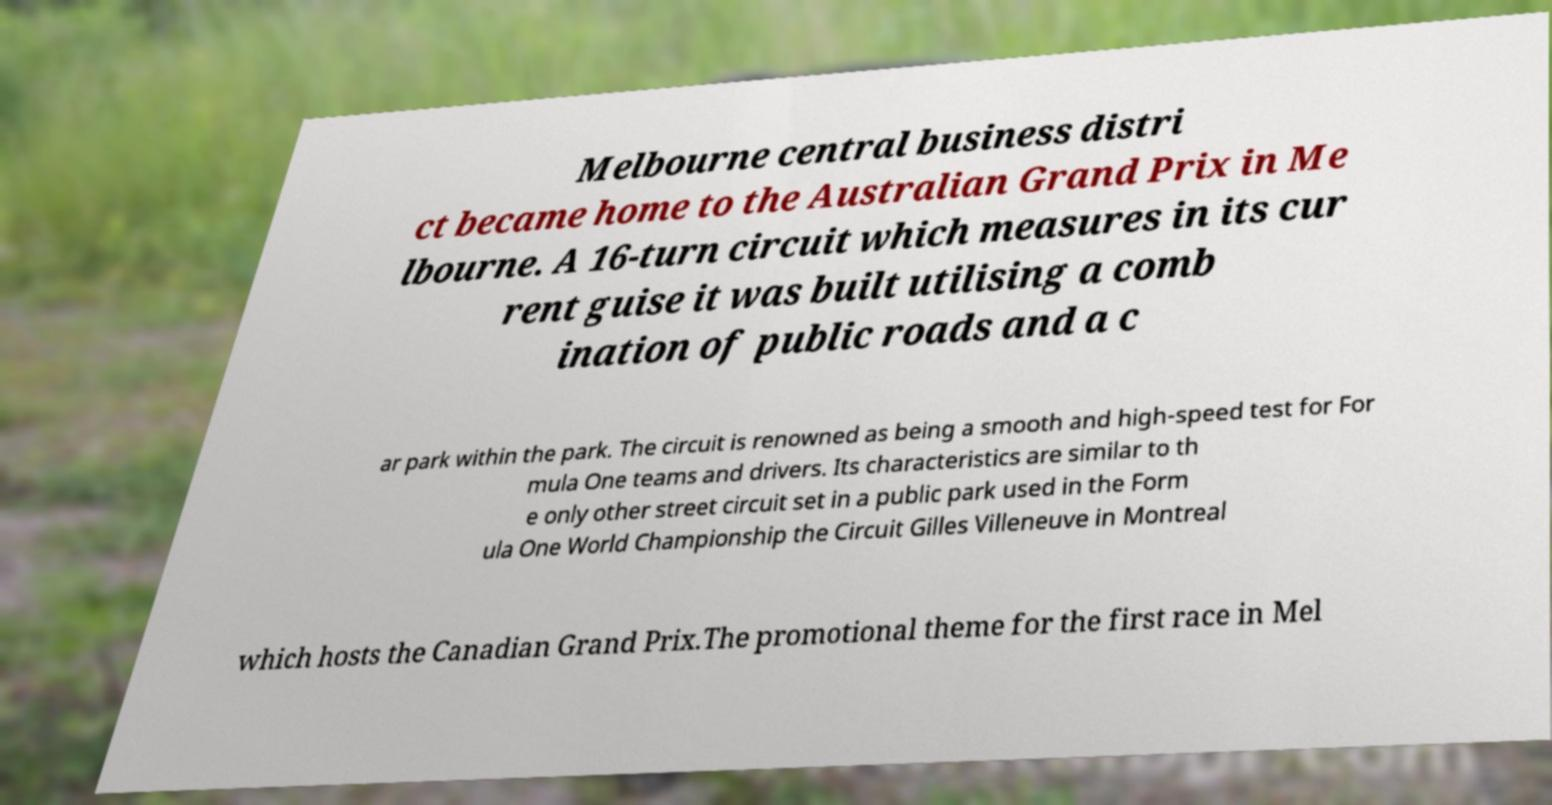Please read and relay the text visible in this image. What does it say? Melbourne central business distri ct became home to the Australian Grand Prix in Me lbourne. A 16-turn circuit which measures in its cur rent guise it was built utilising a comb ination of public roads and a c ar park within the park. The circuit is renowned as being a smooth and high-speed test for For mula One teams and drivers. Its characteristics are similar to th e only other street circuit set in a public park used in the Form ula One World Championship the Circuit Gilles Villeneuve in Montreal which hosts the Canadian Grand Prix.The promotional theme for the first race in Mel 